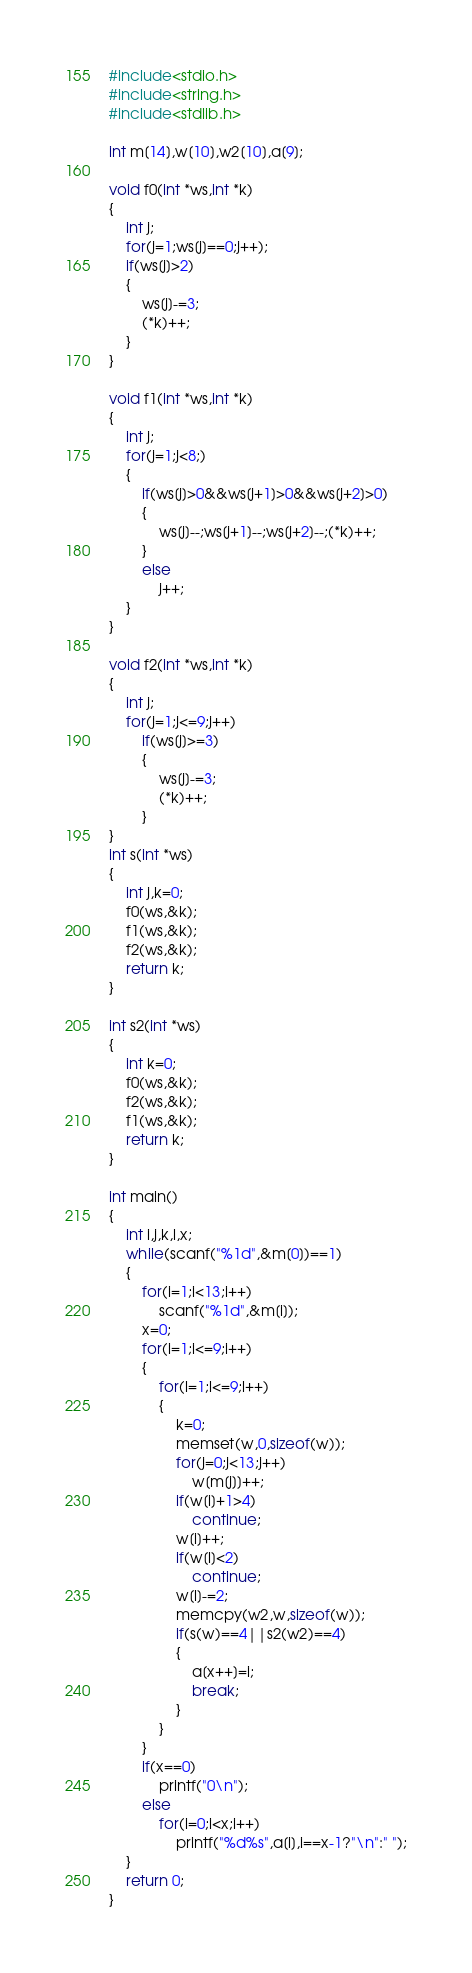<code> <loc_0><loc_0><loc_500><loc_500><_C_>#include<stdio.h>
#include<string.h>
#include<stdlib.h>

int m[14],w[10],w2[10],a[9];

void f0(int *ws,int *k)
{
	int j;
	for(j=1;ws[j]==0;j++);
	if(ws[j]>2)
	{
		ws[j]-=3;
		(*k)++;
	}
}

void f1(int *ws,int *k)
{
	int j;
	for(j=1;j<8;)
	{
		if(ws[j]>0&&ws[j+1]>0&&ws[j+2]>0)
		{
			ws[j]--;ws[j+1]--;ws[j+2]--;(*k)++;
		}
		else
			j++;
	}
}

void f2(int *ws,int *k)
{
	int j;
	for(j=1;j<=9;j++)
		if(ws[j]>=3)
		{
			ws[j]-=3;
			(*k)++;
		}
}
int s(int *ws)
{
	int j,k=0;
	f0(ws,&k);
	f1(ws,&k);
	f2(ws,&k);
	return k;
}

int s2(int *ws)
{
	int k=0;
	f0(ws,&k);
	f2(ws,&k);
	f1(ws,&k);
	return k;
}

int main()
{
	int i,j,k,l,x;
	while(scanf("%1d",&m[0])==1)
	{
		for(i=1;i<13;i++)
			scanf("%1d",&m[i]);
		x=0;
		for(i=1;i<=9;i++)
		{
			for(l=1;l<=9;l++)
			{
				k=0;
				memset(w,0,sizeof(w));
				for(j=0;j<13;j++)
					w[m[j]]++;
				if(w[i]+1>4)
					continue;
				w[i]++;
				if(w[l]<2)
					continue;
				w[l]-=2;
				memcpy(w2,w,sizeof(w));
				if(s(w)==4||s2(w2)==4)
				{
					a[x++]=i;
					break;
				}
			}
		}
		if(x==0)
			printf("0\n");
		else
			for(i=0;i<x;i++)
				printf("%d%s",a[i],i==x-1?"\n":" ");
	}
	return 0;
}</code> 